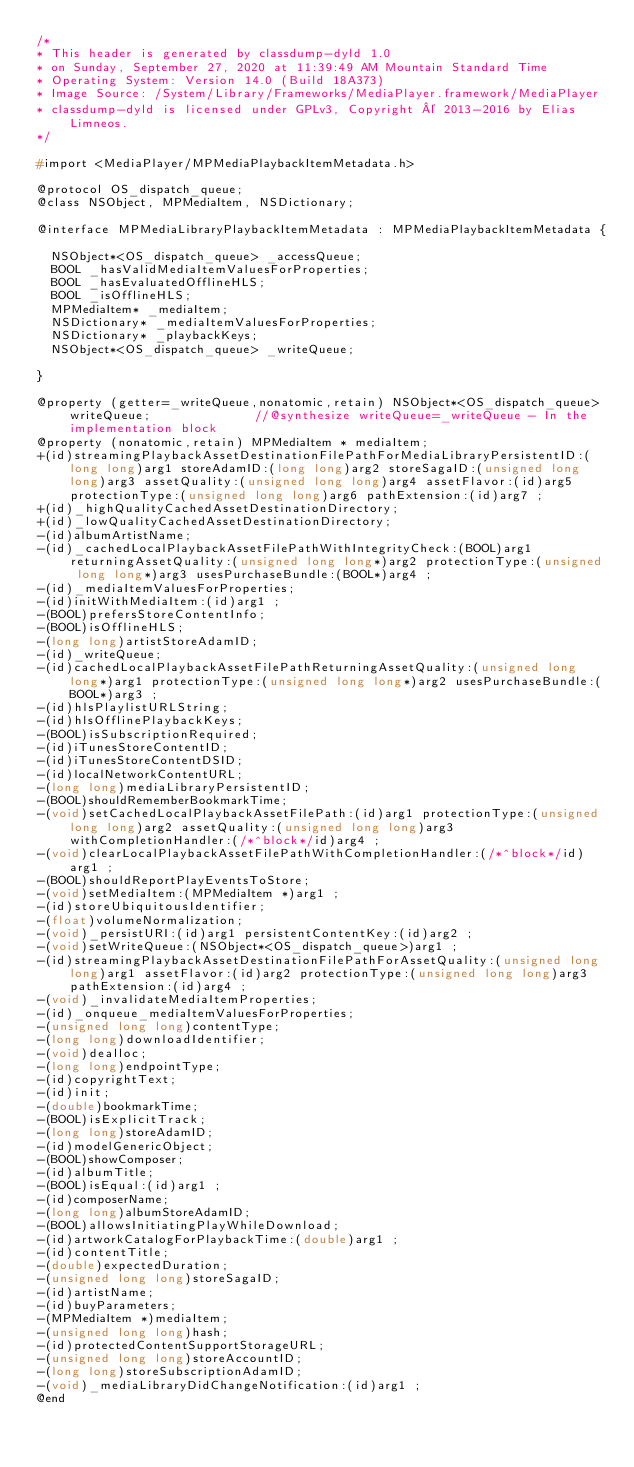<code> <loc_0><loc_0><loc_500><loc_500><_C_>/*
* This header is generated by classdump-dyld 1.0
* on Sunday, September 27, 2020 at 11:39:49 AM Mountain Standard Time
* Operating System: Version 14.0 (Build 18A373)
* Image Source: /System/Library/Frameworks/MediaPlayer.framework/MediaPlayer
* classdump-dyld is licensed under GPLv3, Copyright © 2013-2016 by Elias Limneos.
*/

#import <MediaPlayer/MPMediaPlaybackItemMetadata.h>

@protocol OS_dispatch_queue;
@class NSObject, MPMediaItem, NSDictionary;

@interface MPMediaLibraryPlaybackItemMetadata : MPMediaPlaybackItemMetadata {

	NSObject*<OS_dispatch_queue> _accessQueue;
	BOOL _hasValidMediaItemValuesForProperties;
	BOOL _hasEvaluatedOfflineHLS;
	BOOL _isOfflineHLS;
	MPMediaItem* _mediaItem;
	NSDictionary* _mediaItemValuesForProperties;
	NSDictionary* _playbackKeys;
	NSObject*<OS_dispatch_queue> _writeQueue;

}

@property (getter=_writeQueue,nonatomic,retain) NSObject*<OS_dispatch_queue> writeQueue;              //@synthesize writeQueue=_writeQueue - In the implementation block
@property (nonatomic,retain) MPMediaItem * mediaItem; 
+(id)streamingPlaybackAssetDestinationFilePathForMediaLibraryPersistentID:(long long)arg1 storeAdamID:(long long)arg2 storeSagaID:(unsigned long long)arg3 assetQuality:(unsigned long long)arg4 assetFlavor:(id)arg5 protectionType:(unsigned long long)arg6 pathExtension:(id)arg7 ;
+(id)_highQualityCachedAssetDestinationDirectory;
+(id)_lowQualityCachedAssetDestinationDirectory;
-(id)albumArtistName;
-(id)_cachedLocalPlaybackAssetFilePathWithIntegrityCheck:(BOOL)arg1 returningAssetQuality:(unsigned long long*)arg2 protectionType:(unsigned long long*)arg3 usesPurchaseBundle:(BOOL*)arg4 ;
-(id)_mediaItemValuesForProperties;
-(id)initWithMediaItem:(id)arg1 ;
-(BOOL)prefersStoreContentInfo;
-(BOOL)isOfflineHLS;
-(long long)artistStoreAdamID;
-(id)_writeQueue;
-(id)cachedLocalPlaybackAssetFilePathReturningAssetQuality:(unsigned long long*)arg1 protectionType:(unsigned long long*)arg2 usesPurchaseBundle:(BOOL*)arg3 ;
-(id)hlsPlaylistURLString;
-(id)hlsOfflinePlaybackKeys;
-(BOOL)isSubscriptionRequired;
-(id)iTunesStoreContentID;
-(id)iTunesStoreContentDSID;
-(id)localNetworkContentURL;
-(long long)mediaLibraryPersistentID;
-(BOOL)shouldRememberBookmarkTime;
-(void)setCachedLocalPlaybackAssetFilePath:(id)arg1 protectionType:(unsigned long long)arg2 assetQuality:(unsigned long long)arg3 withCompletionHandler:(/*^block*/id)arg4 ;
-(void)clearLocalPlaybackAssetFilePathWithCompletionHandler:(/*^block*/id)arg1 ;
-(BOOL)shouldReportPlayEventsToStore;
-(void)setMediaItem:(MPMediaItem *)arg1 ;
-(id)storeUbiquitousIdentifier;
-(float)volumeNormalization;
-(void)_persistURI:(id)arg1 persistentContentKey:(id)arg2 ;
-(void)setWriteQueue:(NSObject*<OS_dispatch_queue>)arg1 ;
-(id)streamingPlaybackAssetDestinationFilePathForAssetQuality:(unsigned long long)arg1 assetFlavor:(id)arg2 protectionType:(unsigned long long)arg3 pathExtension:(id)arg4 ;
-(void)_invalidateMediaItemProperties;
-(id)_onqueue_mediaItemValuesForProperties;
-(unsigned long long)contentType;
-(long long)downloadIdentifier;
-(void)dealloc;
-(long long)endpointType;
-(id)copyrightText;
-(id)init;
-(double)bookmarkTime;
-(BOOL)isExplicitTrack;
-(long long)storeAdamID;
-(id)modelGenericObject;
-(BOOL)showComposer;
-(id)albumTitle;
-(BOOL)isEqual:(id)arg1 ;
-(id)composerName;
-(long long)albumStoreAdamID;
-(BOOL)allowsInitiatingPlayWhileDownload;
-(id)artworkCatalogForPlaybackTime:(double)arg1 ;
-(id)contentTitle;
-(double)expectedDuration;
-(unsigned long long)storeSagaID;
-(id)artistName;
-(id)buyParameters;
-(MPMediaItem *)mediaItem;
-(unsigned long long)hash;
-(id)protectedContentSupportStorageURL;
-(unsigned long long)storeAccountID;
-(long long)storeSubscriptionAdamID;
-(void)_mediaLibraryDidChangeNotification:(id)arg1 ;
@end

</code> 